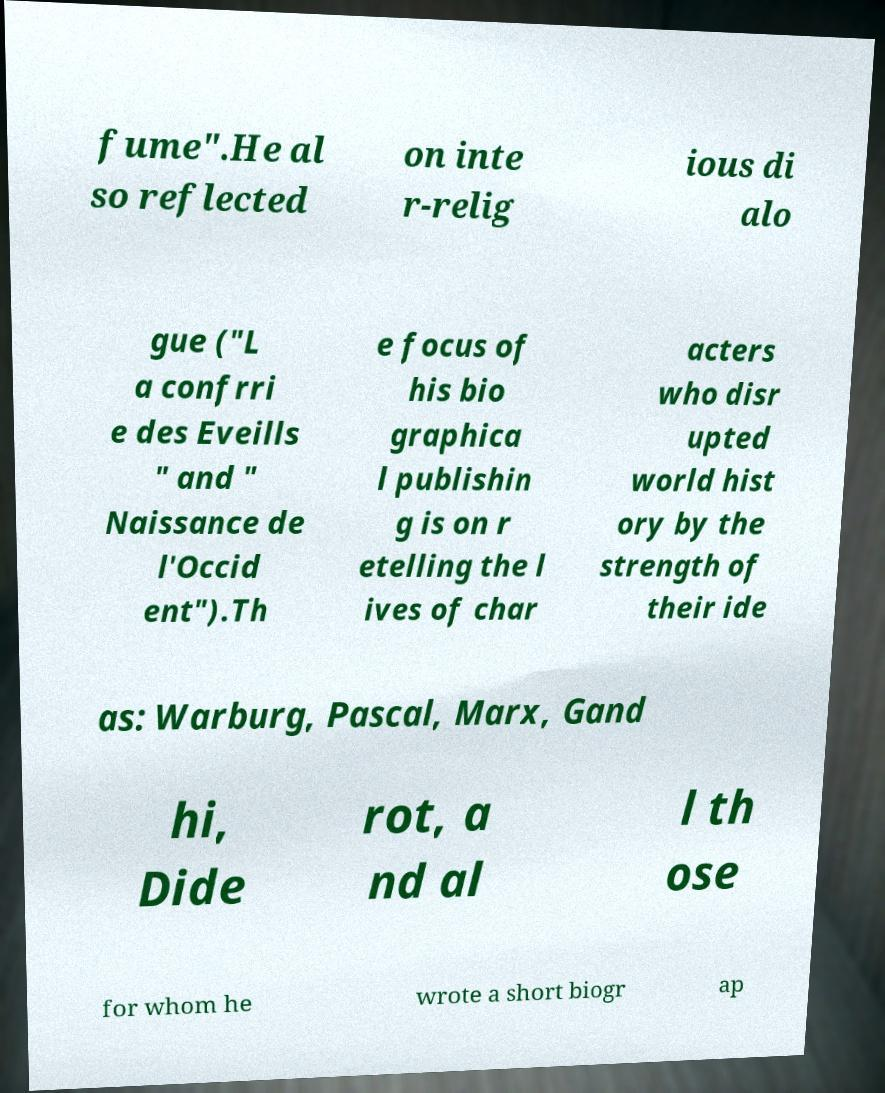Could you assist in decoding the text presented in this image and type it out clearly? fume".He al so reflected on inte r-relig ious di alo gue ("L a confrri e des Eveills " and " Naissance de l'Occid ent").Th e focus of his bio graphica l publishin g is on r etelling the l ives of char acters who disr upted world hist ory by the strength of their ide as: Warburg, Pascal, Marx, Gand hi, Dide rot, a nd al l th ose for whom he wrote a short biogr ap 